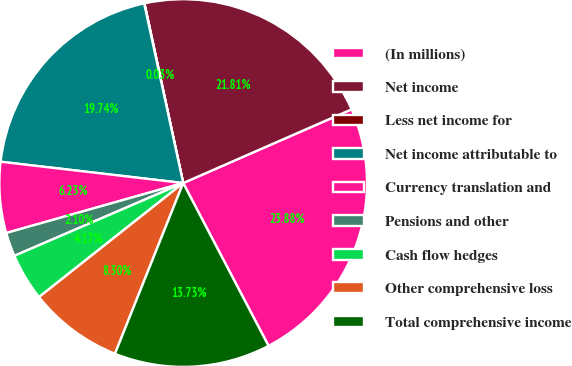Convert chart. <chart><loc_0><loc_0><loc_500><loc_500><pie_chart><fcel>(In millions)<fcel>Net income<fcel>Less net income for<fcel>Net income attributable to<fcel>Currency translation and<fcel>Pensions and other<fcel>Cash flow hedges<fcel>Other comprehensive loss<fcel>Total comprehensive income<nl><fcel>23.88%<fcel>21.81%<fcel>0.03%<fcel>19.74%<fcel>6.23%<fcel>2.1%<fcel>4.17%<fcel>8.3%<fcel>13.73%<nl></chart> 